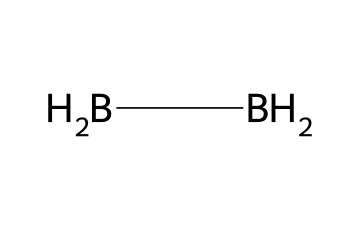What is the molecular formula of diborane? The molecular formula can be derived from the SMILES representation. In this case, we have two boron (B) atoms and six hydrogen (H) atoms, forming the compound B2H6.
Answer: B2H6 How many total hydrogen atoms are present in diborane? From the SMILES representation [BH2][BH2], it is clear that each boron atom is bonded to two hydrogen atoms. Since there are two boron atoms, the total is 2 hydrogen atoms per boron multiplied by 2 boron atoms, resulting in 4 hydrogen atoms. However, as there is an additional bridging hydrogen atom, the overall total becomes 6.
Answer: 6 Which type of bonding is predominant in diborane? In diborane, the bonding primarily involves covalent bonding between boron and hydrogen atoms. The structure showcases these bonds distinctly.
Answer: covalent What is the hybridization of the boron atoms in diborane? The boron atoms in diborane are bonded in a way that requires sp3 hybridization, as indicated by the tetrahedral arrangement around each boron atom, with one of the bonds being a bridge.
Answer: sp3 Is diborane a Lewis acid or Lewis base? Diborane acts as a Lewis acid because it can accept electron pairs due to the electron-deficient nature of boron in the molecule.
Answer: Lewis acid How many total bonds are present in diborane? Analyzing the structure from the SMILES representation, each boron atom forms three total bonds: two with hydrogen atoms and one with the other boron atom, leading to a total of 6 bonds in diborane.
Answer: 6 